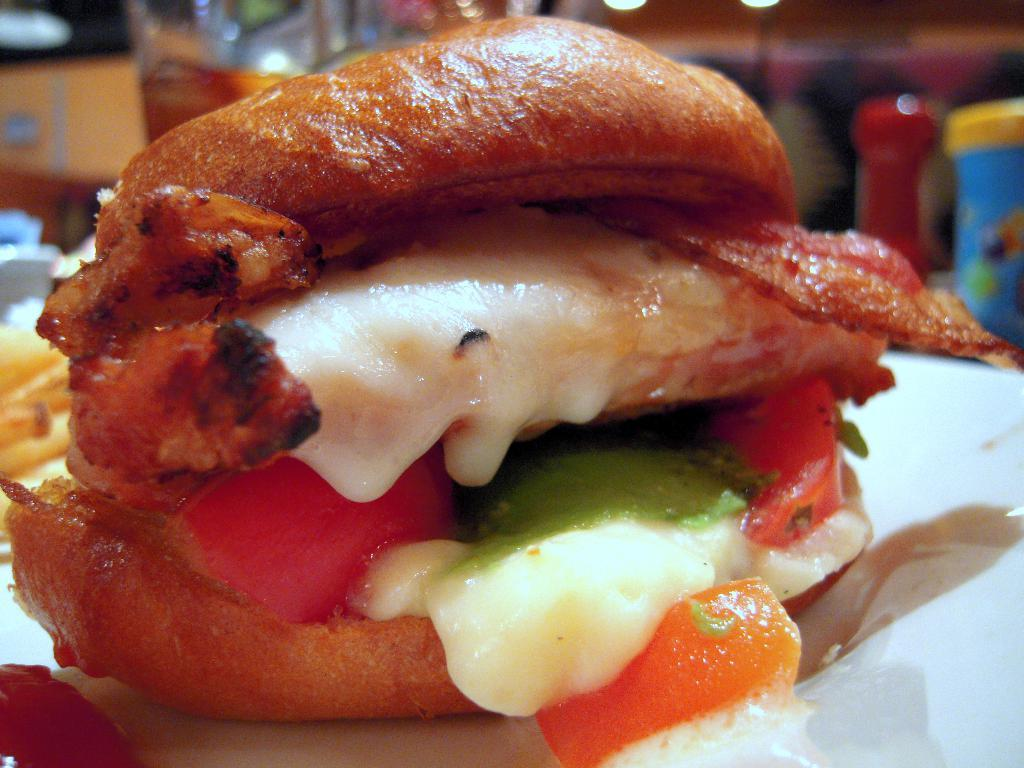What is the focus of the image? The image is a zoomed-in view, with a food item in the foreground. What type of food item is in the foreground? The food item in the foreground appears to be a hot-dog. What can be seen in the background of the image? There are many items visible in the background. What channel is the train passing through in the image? There is no train or channel present in the image; it features a zoomed-in view of a hot-dog in the foreground and many items in the background. 